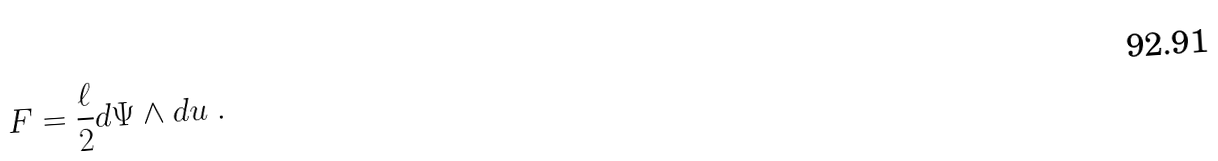<formula> <loc_0><loc_0><loc_500><loc_500>F = { \frac { \ell } { 2 } } d \Psi \wedge d u \text { } .</formula> 